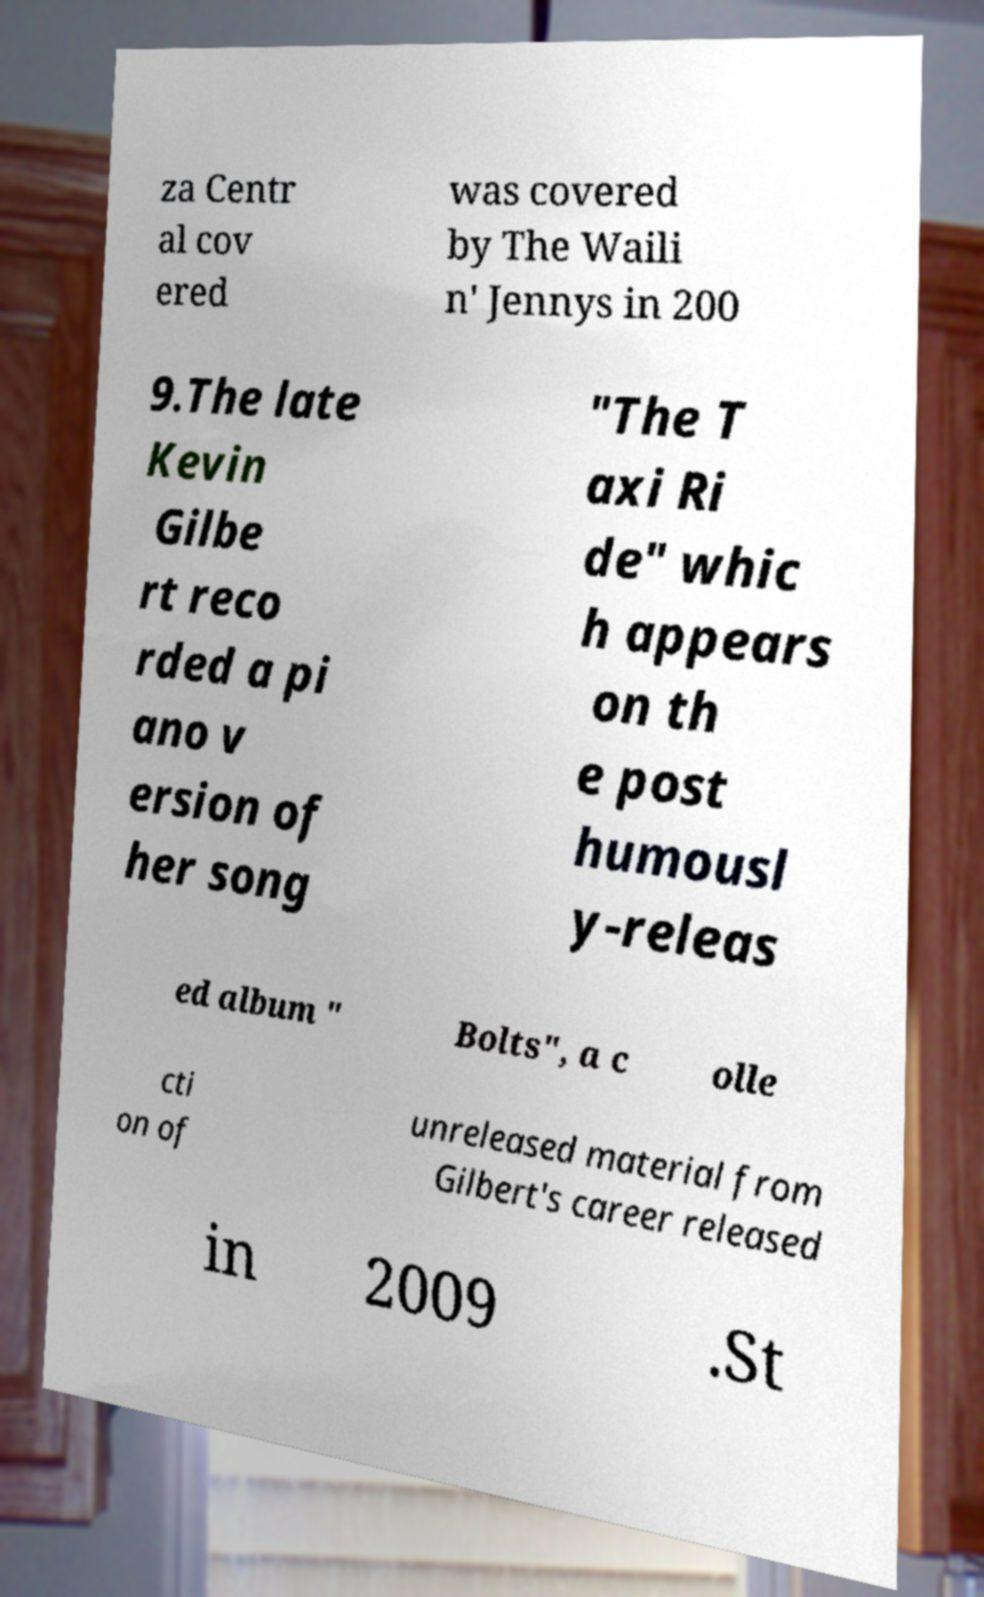For documentation purposes, I need the text within this image transcribed. Could you provide that? za Centr al cov ered was covered by The Waili n' Jennys in 200 9.The late Kevin Gilbe rt reco rded a pi ano v ersion of her song "The T axi Ri de" whic h appears on th e post humousl y-releas ed album " Bolts", a c olle cti on of unreleased material from Gilbert's career released in 2009 .St 